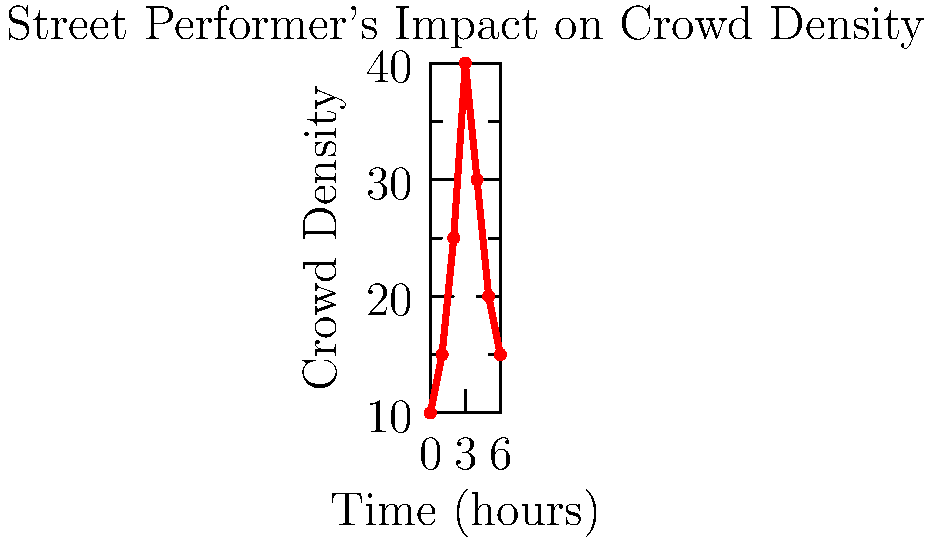Analyze the graph depicting crowd density patterns around a street performer over time. What sociological insight can be drawn about the performer's impact on urban dynamics, and at which point does the crowd reach its peak density? To answer this question, we need to analyze the graph and interpret its sociological implications:

1. Pattern recognition: The graph shows an initial increase in crowd density, followed by a peak, and then a decline.

2. Urban dynamics interpretation:
   a) Initial growth (0-3 hours): Represents the performer's ability to attract and engage passersby, transforming the urban space into a temporary cultural hub.
   b) Peak (at 3 hours): Indicates the maximum impact of the performance on the urban landscape, where the street corner becomes a focal point of social interaction.
   c) Decline (3-6 hours): Suggests audience saturation or natural dispersion as urban rhythms shift.

3. Sociological insights:
   - The street performer acts as a catalyst for temporary community formation in urban spaces.
   - The performance creates a dynamic ebb and flow of social density, altering the usual patterns of urban movement.
   - The temporary nature of the crowd highlights the ephemeral quality of street art and its impact on urban social fabric.

4. Peak density:
   By examining the graph, we can see that the crowd density reaches its highest point at the 3-hour mark.
Answer: Street performers create temporary social hubs, peaking at 3 hours. 